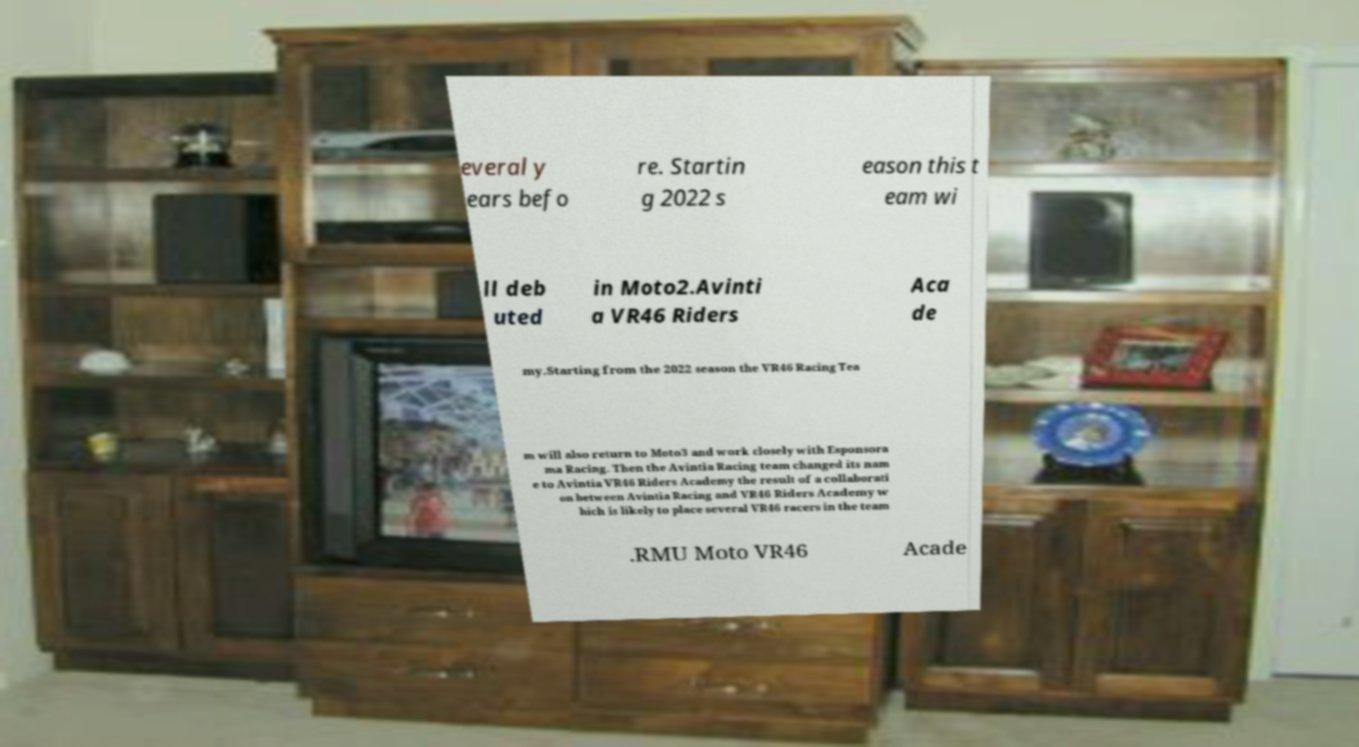Can you read and provide the text displayed in the image?This photo seems to have some interesting text. Can you extract and type it out for me? everal y ears befo re. Startin g 2022 s eason this t eam wi ll deb uted in Moto2.Avinti a VR46 Riders Aca de my.Starting from the 2022 season the VR46 Racing Tea m will also return to Moto3 and work closely with Esponsora ma Racing. Then the Avintia Racing team changed its nam e to Avintia VR46 Riders Academy the result of a collaborati on between Avintia Racing and VR46 Riders Academy w hich is likely to place several VR46 racers in the team .RMU Moto VR46 Acade 